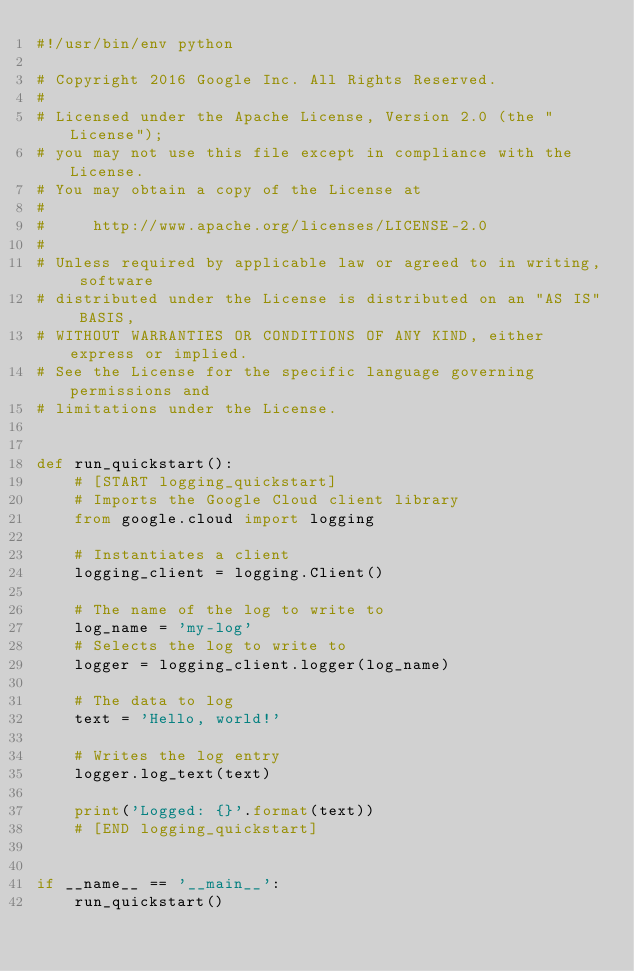Convert code to text. <code><loc_0><loc_0><loc_500><loc_500><_Python_>#!/usr/bin/env python

# Copyright 2016 Google Inc. All Rights Reserved.
#
# Licensed under the Apache License, Version 2.0 (the "License");
# you may not use this file except in compliance with the License.
# You may obtain a copy of the License at
#
#     http://www.apache.org/licenses/LICENSE-2.0
#
# Unless required by applicable law or agreed to in writing, software
# distributed under the License is distributed on an "AS IS" BASIS,
# WITHOUT WARRANTIES OR CONDITIONS OF ANY KIND, either express or implied.
# See the License for the specific language governing permissions and
# limitations under the License.


def run_quickstart():
    # [START logging_quickstart]
    # Imports the Google Cloud client library
    from google.cloud import logging

    # Instantiates a client
    logging_client = logging.Client()

    # The name of the log to write to
    log_name = 'my-log'
    # Selects the log to write to
    logger = logging_client.logger(log_name)

    # The data to log
    text = 'Hello, world!'

    # Writes the log entry
    logger.log_text(text)

    print('Logged: {}'.format(text))
    # [END logging_quickstart]


if __name__ == '__main__':
    run_quickstart()
</code> 